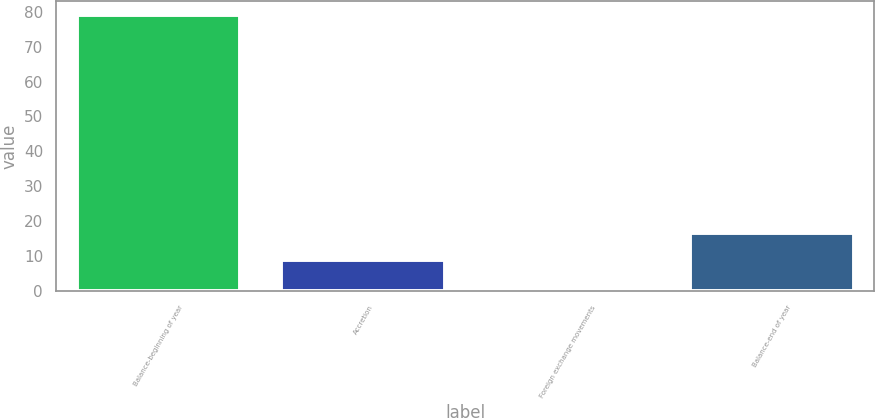Convert chart. <chart><loc_0><loc_0><loc_500><loc_500><bar_chart><fcel>Balance-beginning of year<fcel>Accretion<fcel>Foreign exchange movements<fcel>Balance-end of year<nl><fcel>79<fcel>8.8<fcel>1<fcel>16.6<nl></chart> 